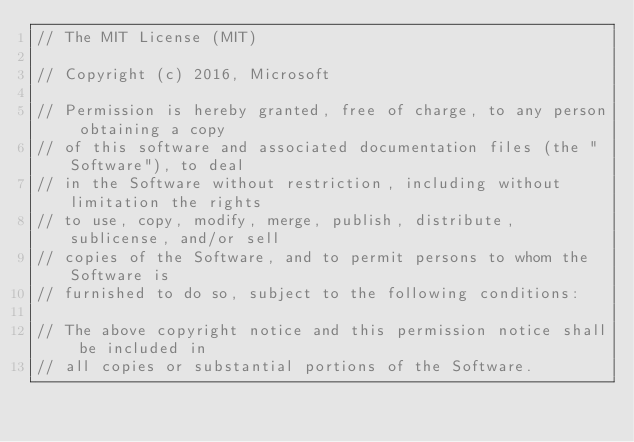Convert code to text. <code><loc_0><loc_0><loc_500><loc_500><_C++_>// The MIT License (MIT)

// Copyright (c) 2016, Microsoft

// Permission is hereby granted, free of charge, to any person obtaining a copy
// of this software and associated documentation files (the "Software"), to deal
// in the Software without restriction, including without limitation the rights
// to use, copy, modify, merge, publish, distribute, sublicense, and/or sell
// copies of the Software, and to permit persons to whom the Software is
// furnished to do so, subject to the following conditions:

// The above copyright notice and this permission notice shall be included in
// all copies or substantial portions of the Software.
</code> 